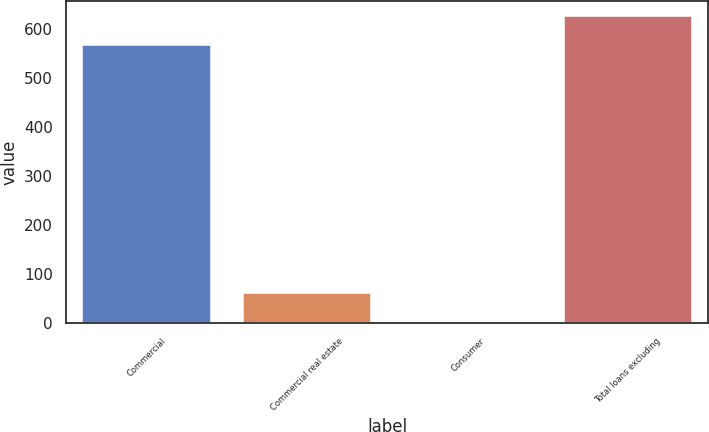Convert chart. <chart><loc_0><loc_0><loc_500><loc_500><bar_chart><fcel>Commercial<fcel>Commercial real estate<fcel>Consumer<fcel>Total loans excluding<nl><fcel>567<fcel>61.7<fcel>3<fcel>625.7<nl></chart> 